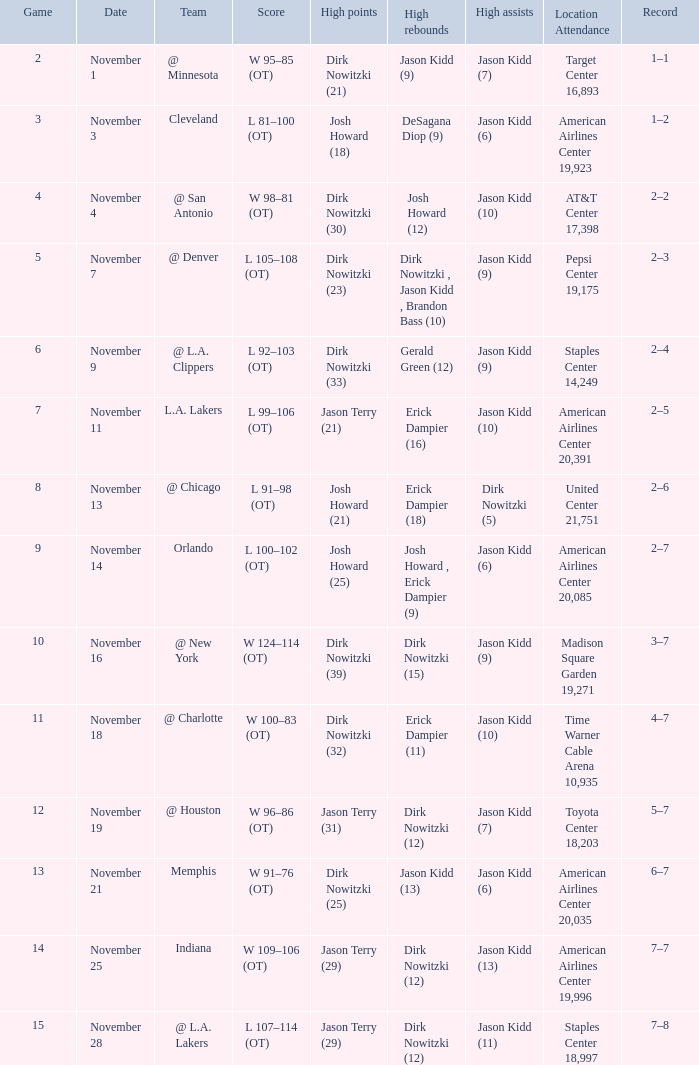What was the record on November 7? 1.0. 